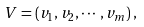<formula> <loc_0><loc_0><loc_500><loc_500>V = \left ( v _ { 1 } , v _ { 2 } , \cdots , v _ { m } \right ) ,</formula> 